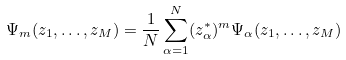<formula> <loc_0><loc_0><loc_500><loc_500>\Psi _ { m } ( z _ { 1 } , \dots , z _ { M } ) = \frac { 1 } { N } \sum _ { \alpha = 1 } ^ { N } ( z _ { \alpha } ^ { * } ) ^ { m } \Psi _ { \alpha } ( z _ { 1 } , \dots , z _ { M } )</formula> 